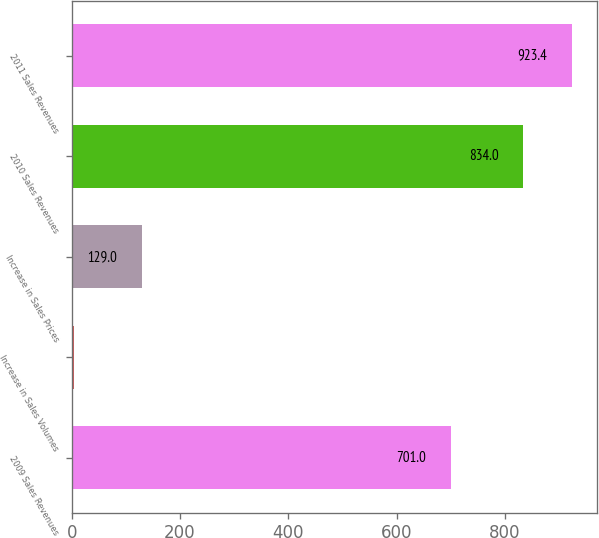<chart> <loc_0><loc_0><loc_500><loc_500><bar_chart><fcel>2009 Sales Revenues<fcel>Increase in Sales Volumes<fcel>Increase in Sales Prices<fcel>2010 Sales Revenues<fcel>2011 Sales Revenues<nl><fcel>701<fcel>5<fcel>129<fcel>834<fcel>923.4<nl></chart> 